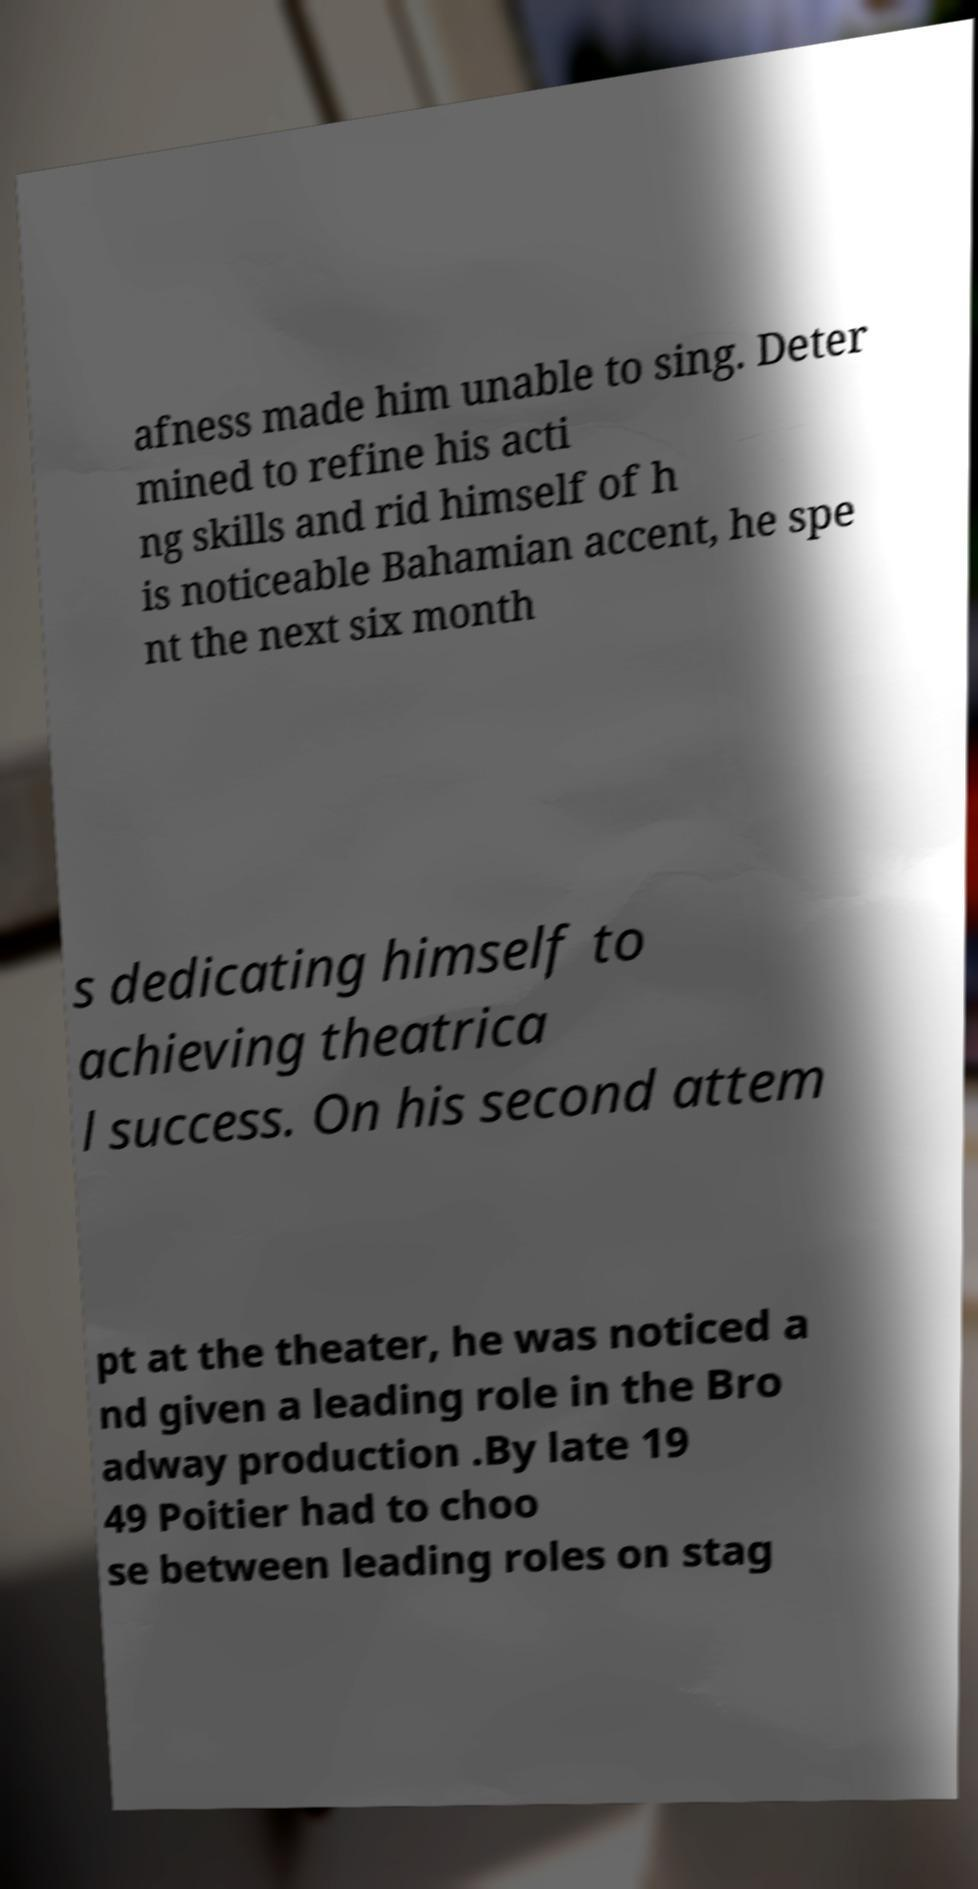I need the written content from this picture converted into text. Can you do that? afness made him unable to sing. Deter mined to refine his acti ng skills and rid himself of h is noticeable Bahamian accent, he spe nt the next six month s dedicating himself to achieving theatrica l success. On his second attem pt at the theater, he was noticed a nd given a leading role in the Bro adway production .By late 19 49 Poitier had to choo se between leading roles on stag 